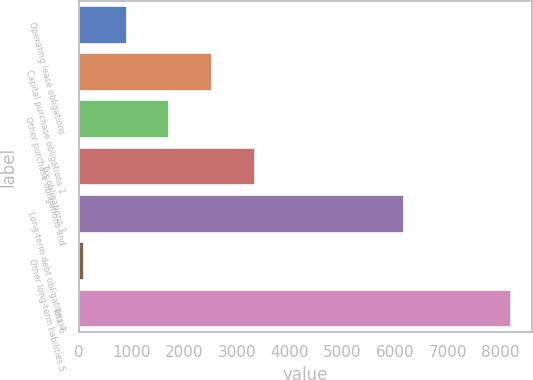<chart> <loc_0><loc_0><loc_500><loc_500><bar_chart><fcel>Operating lease obligations<fcel>Capital purchase obligations 1<fcel>Other purchase obligations and<fcel>Tax obligations 3<fcel>Long-term debt obligations 4<fcel>Other long-term liabilities 5<fcel>Total 6<nl><fcel>905.1<fcel>2525.3<fcel>1715.2<fcel>3335.4<fcel>6173<fcel>95<fcel>8196<nl></chart> 